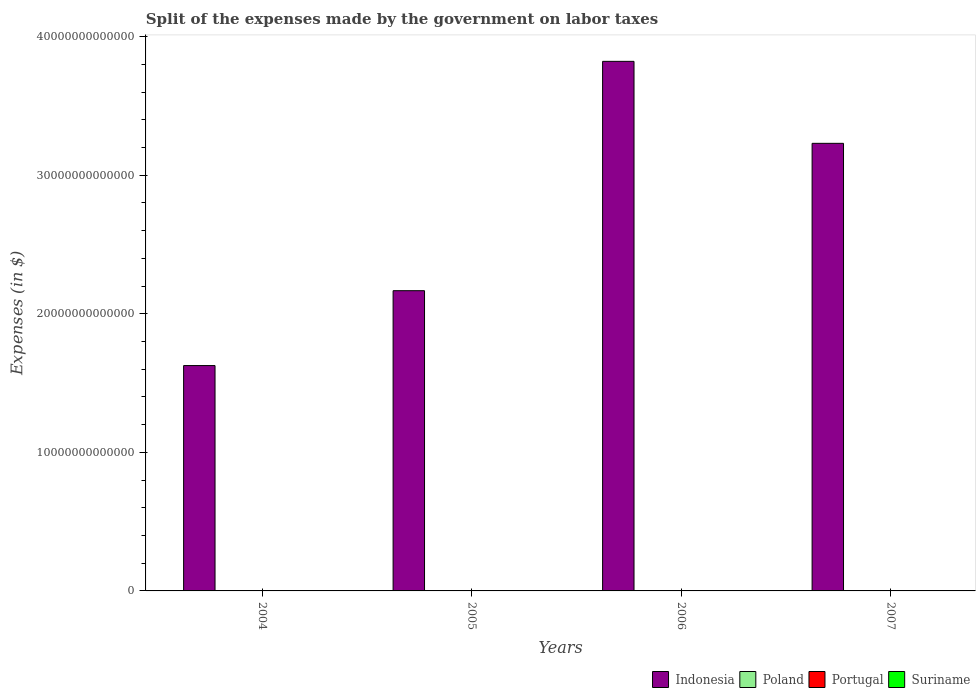How many groups of bars are there?
Provide a short and direct response. 4. Are the number of bars per tick equal to the number of legend labels?
Offer a terse response. Yes. Are the number of bars on each tick of the X-axis equal?
Make the answer very short. Yes. How many bars are there on the 4th tick from the left?
Your response must be concise. 4. In how many cases, is the number of bars for a given year not equal to the number of legend labels?
Make the answer very short. 0. What is the expenses made by the government on labor taxes in Suriname in 2007?
Offer a very short reply. 7.59e+07. Across all years, what is the maximum expenses made by the government on labor taxes in Suriname?
Make the answer very short. 7.59e+07. Across all years, what is the minimum expenses made by the government on labor taxes in Portugal?
Your answer should be compact. 1.18e+09. In which year was the expenses made by the government on labor taxes in Poland maximum?
Your answer should be compact. 2007. In which year was the expenses made by the government on labor taxes in Portugal minimum?
Offer a terse response. 2004. What is the total expenses made by the government on labor taxes in Portugal in the graph?
Your answer should be very brief. 5.30e+09. What is the difference between the expenses made by the government on labor taxes in Indonesia in 2005 and that in 2006?
Give a very brief answer. -1.65e+13. What is the difference between the expenses made by the government on labor taxes in Indonesia in 2006 and the expenses made by the government on labor taxes in Portugal in 2004?
Offer a terse response. 3.82e+13. What is the average expenses made by the government on labor taxes in Poland per year?
Keep it short and to the point. 2.67e+09. In the year 2004, what is the difference between the expenses made by the government on labor taxes in Suriname and expenses made by the government on labor taxes in Indonesia?
Your answer should be very brief. -1.63e+13. What is the ratio of the expenses made by the government on labor taxes in Indonesia in 2005 to that in 2006?
Offer a very short reply. 0.57. Is the difference between the expenses made by the government on labor taxes in Suriname in 2005 and 2007 greater than the difference between the expenses made by the government on labor taxes in Indonesia in 2005 and 2007?
Make the answer very short. Yes. What is the difference between the highest and the second highest expenses made by the government on labor taxes in Poland?
Give a very brief answer. 1.49e+08. What is the difference between the highest and the lowest expenses made by the government on labor taxes in Indonesia?
Provide a short and direct response. 2.20e+13. What does the 1st bar from the left in 2006 represents?
Give a very brief answer. Indonesia. How many bars are there?
Ensure brevity in your answer.  16. Are all the bars in the graph horizontal?
Offer a terse response. No. How many years are there in the graph?
Your answer should be very brief. 4. What is the difference between two consecutive major ticks on the Y-axis?
Provide a succinct answer. 1.00e+13. Does the graph contain grids?
Give a very brief answer. No. Where does the legend appear in the graph?
Your response must be concise. Bottom right. What is the title of the graph?
Ensure brevity in your answer.  Split of the expenses made by the government on labor taxes. Does "Spain" appear as one of the legend labels in the graph?
Your answer should be very brief. No. What is the label or title of the Y-axis?
Provide a succinct answer. Expenses (in $). What is the Expenses (in $) of Indonesia in 2004?
Provide a succinct answer. 1.63e+13. What is the Expenses (in $) of Poland in 2004?
Offer a terse response. 2.17e+09. What is the Expenses (in $) in Portugal in 2004?
Give a very brief answer. 1.18e+09. What is the Expenses (in $) of Suriname in 2004?
Provide a short and direct response. 4.07e+07. What is the Expenses (in $) of Indonesia in 2005?
Your answer should be compact. 2.17e+13. What is the Expenses (in $) in Poland in 2005?
Provide a succinct answer. 2.50e+09. What is the Expenses (in $) of Portugal in 2005?
Make the answer very short. 1.29e+09. What is the Expenses (in $) in Suriname in 2005?
Provide a short and direct response. 4.94e+07. What is the Expenses (in $) in Indonesia in 2006?
Make the answer very short. 3.82e+13. What is the Expenses (in $) in Poland in 2006?
Offer a terse response. 2.93e+09. What is the Expenses (in $) of Portugal in 2006?
Keep it short and to the point. 1.39e+09. What is the Expenses (in $) of Suriname in 2006?
Make the answer very short. 6.16e+07. What is the Expenses (in $) in Indonesia in 2007?
Offer a very short reply. 3.23e+13. What is the Expenses (in $) in Poland in 2007?
Make the answer very short. 3.08e+09. What is the Expenses (in $) in Portugal in 2007?
Give a very brief answer. 1.44e+09. What is the Expenses (in $) in Suriname in 2007?
Provide a succinct answer. 7.59e+07. Across all years, what is the maximum Expenses (in $) of Indonesia?
Offer a terse response. 3.82e+13. Across all years, what is the maximum Expenses (in $) in Poland?
Make the answer very short. 3.08e+09. Across all years, what is the maximum Expenses (in $) in Portugal?
Keep it short and to the point. 1.44e+09. Across all years, what is the maximum Expenses (in $) in Suriname?
Your answer should be compact. 7.59e+07. Across all years, what is the minimum Expenses (in $) of Indonesia?
Your response must be concise. 1.63e+13. Across all years, what is the minimum Expenses (in $) of Poland?
Keep it short and to the point. 2.17e+09. Across all years, what is the minimum Expenses (in $) in Portugal?
Offer a very short reply. 1.18e+09. Across all years, what is the minimum Expenses (in $) in Suriname?
Keep it short and to the point. 4.07e+07. What is the total Expenses (in $) of Indonesia in the graph?
Offer a terse response. 1.08e+14. What is the total Expenses (in $) in Poland in the graph?
Give a very brief answer. 1.07e+1. What is the total Expenses (in $) in Portugal in the graph?
Give a very brief answer. 5.30e+09. What is the total Expenses (in $) of Suriname in the graph?
Your answer should be compact. 2.28e+08. What is the difference between the Expenses (in $) of Indonesia in 2004 and that in 2005?
Ensure brevity in your answer.  -5.40e+12. What is the difference between the Expenses (in $) in Poland in 2004 and that in 2005?
Your answer should be compact. -3.30e+08. What is the difference between the Expenses (in $) in Portugal in 2004 and that in 2005?
Your answer should be very brief. -1.15e+08. What is the difference between the Expenses (in $) of Suriname in 2004 and that in 2005?
Your answer should be very brief. -8.70e+06. What is the difference between the Expenses (in $) in Indonesia in 2004 and that in 2006?
Make the answer very short. -2.20e+13. What is the difference between the Expenses (in $) in Poland in 2004 and that in 2006?
Your answer should be compact. -7.57e+08. What is the difference between the Expenses (in $) of Portugal in 2004 and that in 2006?
Keep it short and to the point. -2.15e+08. What is the difference between the Expenses (in $) in Suriname in 2004 and that in 2006?
Provide a short and direct response. -2.09e+07. What is the difference between the Expenses (in $) of Indonesia in 2004 and that in 2007?
Offer a terse response. -1.60e+13. What is the difference between the Expenses (in $) of Poland in 2004 and that in 2007?
Offer a terse response. -9.06e+08. What is the difference between the Expenses (in $) of Portugal in 2004 and that in 2007?
Give a very brief answer. -2.58e+08. What is the difference between the Expenses (in $) of Suriname in 2004 and that in 2007?
Make the answer very short. -3.51e+07. What is the difference between the Expenses (in $) of Indonesia in 2005 and that in 2006?
Offer a terse response. -1.65e+13. What is the difference between the Expenses (in $) of Poland in 2005 and that in 2006?
Provide a short and direct response. -4.27e+08. What is the difference between the Expenses (in $) of Portugal in 2005 and that in 2006?
Offer a very short reply. -1.00e+08. What is the difference between the Expenses (in $) in Suriname in 2005 and that in 2006?
Offer a terse response. -1.22e+07. What is the difference between the Expenses (in $) of Indonesia in 2005 and that in 2007?
Offer a very short reply. -1.06e+13. What is the difference between the Expenses (in $) of Poland in 2005 and that in 2007?
Your response must be concise. -5.76e+08. What is the difference between the Expenses (in $) of Portugal in 2005 and that in 2007?
Provide a short and direct response. -1.43e+08. What is the difference between the Expenses (in $) of Suriname in 2005 and that in 2007?
Offer a very short reply. -2.64e+07. What is the difference between the Expenses (in $) of Indonesia in 2006 and that in 2007?
Provide a short and direct response. 5.92e+12. What is the difference between the Expenses (in $) in Poland in 2006 and that in 2007?
Keep it short and to the point. -1.49e+08. What is the difference between the Expenses (in $) in Portugal in 2006 and that in 2007?
Make the answer very short. -4.29e+07. What is the difference between the Expenses (in $) in Suriname in 2006 and that in 2007?
Your response must be concise. -1.43e+07. What is the difference between the Expenses (in $) in Indonesia in 2004 and the Expenses (in $) in Poland in 2005?
Your answer should be very brief. 1.63e+13. What is the difference between the Expenses (in $) of Indonesia in 2004 and the Expenses (in $) of Portugal in 2005?
Give a very brief answer. 1.63e+13. What is the difference between the Expenses (in $) of Indonesia in 2004 and the Expenses (in $) of Suriname in 2005?
Your answer should be very brief. 1.63e+13. What is the difference between the Expenses (in $) in Poland in 2004 and the Expenses (in $) in Portugal in 2005?
Your answer should be compact. 8.81e+08. What is the difference between the Expenses (in $) of Poland in 2004 and the Expenses (in $) of Suriname in 2005?
Keep it short and to the point. 2.12e+09. What is the difference between the Expenses (in $) in Portugal in 2004 and the Expenses (in $) in Suriname in 2005?
Your answer should be compact. 1.13e+09. What is the difference between the Expenses (in $) of Indonesia in 2004 and the Expenses (in $) of Poland in 2006?
Offer a terse response. 1.63e+13. What is the difference between the Expenses (in $) in Indonesia in 2004 and the Expenses (in $) in Portugal in 2006?
Ensure brevity in your answer.  1.63e+13. What is the difference between the Expenses (in $) in Indonesia in 2004 and the Expenses (in $) in Suriname in 2006?
Your response must be concise. 1.63e+13. What is the difference between the Expenses (in $) of Poland in 2004 and the Expenses (in $) of Portugal in 2006?
Your response must be concise. 7.80e+08. What is the difference between the Expenses (in $) of Poland in 2004 and the Expenses (in $) of Suriname in 2006?
Your response must be concise. 2.11e+09. What is the difference between the Expenses (in $) in Portugal in 2004 and the Expenses (in $) in Suriname in 2006?
Your answer should be compact. 1.12e+09. What is the difference between the Expenses (in $) of Indonesia in 2004 and the Expenses (in $) of Poland in 2007?
Your answer should be very brief. 1.63e+13. What is the difference between the Expenses (in $) in Indonesia in 2004 and the Expenses (in $) in Portugal in 2007?
Offer a terse response. 1.63e+13. What is the difference between the Expenses (in $) in Indonesia in 2004 and the Expenses (in $) in Suriname in 2007?
Offer a very short reply. 1.63e+13. What is the difference between the Expenses (in $) in Poland in 2004 and the Expenses (in $) in Portugal in 2007?
Keep it short and to the point. 7.38e+08. What is the difference between the Expenses (in $) of Poland in 2004 and the Expenses (in $) of Suriname in 2007?
Provide a short and direct response. 2.10e+09. What is the difference between the Expenses (in $) in Portugal in 2004 and the Expenses (in $) in Suriname in 2007?
Your answer should be compact. 1.10e+09. What is the difference between the Expenses (in $) of Indonesia in 2005 and the Expenses (in $) of Poland in 2006?
Make the answer very short. 2.17e+13. What is the difference between the Expenses (in $) of Indonesia in 2005 and the Expenses (in $) of Portugal in 2006?
Provide a succinct answer. 2.17e+13. What is the difference between the Expenses (in $) in Indonesia in 2005 and the Expenses (in $) in Suriname in 2006?
Provide a short and direct response. 2.17e+13. What is the difference between the Expenses (in $) in Poland in 2005 and the Expenses (in $) in Portugal in 2006?
Offer a terse response. 1.11e+09. What is the difference between the Expenses (in $) in Poland in 2005 and the Expenses (in $) in Suriname in 2006?
Make the answer very short. 2.44e+09. What is the difference between the Expenses (in $) in Portugal in 2005 and the Expenses (in $) in Suriname in 2006?
Provide a succinct answer. 1.23e+09. What is the difference between the Expenses (in $) of Indonesia in 2005 and the Expenses (in $) of Poland in 2007?
Your answer should be very brief. 2.17e+13. What is the difference between the Expenses (in $) in Indonesia in 2005 and the Expenses (in $) in Portugal in 2007?
Your answer should be very brief. 2.17e+13. What is the difference between the Expenses (in $) of Indonesia in 2005 and the Expenses (in $) of Suriname in 2007?
Provide a short and direct response. 2.17e+13. What is the difference between the Expenses (in $) in Poland in 2005 and the Expenses (in $) in Portugal in 2007?
Give a very brief answer. 1.07e+09. What is the difference between the Expenses (in $) of Poland in 2005 and the Expenses (in $) of Suriname in 2007?
Offer a terse response. 2.43e+09. What is the difference between the Expenses (in $) in Portugal in 2005 and the Expenses (in $) in Suriname in 2007?
Your answer should be compact. 1.22e+09. What is the difference between the Expenses (in $) of Indonesia in 2006 and the Expenses (in $) of Poland in 2007?
Make the answer very short. 3.82e+13. What is the difference between the Expenses (in $) in Indonesia in 2006 and the Expenses (in $) in Portugal in 2007?
Provide a short and direct response. 3.82e+13. What is the difference between the Expenses (in $) of Indonesia in 2006 and the Expenses (in $) of Suriname in 2007?
Provide a short and direct response. 3.82e+13. What is the difference between the Expenses (in $) of Poland in 2006 and the Expenses (in $) of Portugal in 2007?
Make the answer very short. 1.49e+09. What is the difference between the Expenses (in $) of Poland in 2006 and the Expenses (in $) of Suriname in 2007?
Your answer should be very brief. 2.86e+09. What is the difference between the Expenses (in $) of Portugal in 2006 and the Expenses (in $) of Suriname in 2007?
Offer a terse response. 1.32e+09. What is the average Expenses (in $) in Indonesia per year?
Your answer should be compact. 2.71e+13. What is the average Expenses (in $) of Poland per year?
Keep it short and to the point. 2.67e+09. What is the average Expenses (in $) of Portugal per year?
Provide a succinct answer. 1.33e+09. What is the average Expenses (in $) in Suriname per year?
Give a very brief answer. 5.69e+07. In the year 2004, what is the difference between the Expenses (in $) in Indonesia and Expenses (in $) in Poland?
Keep it short and to the point. 1.63e+13. In the year 2004, what is the difference between the Expenses (in $) in Indonesia and Expenses (in $) in Portugal?
Ensure brevity in your answer.  1.63e+13. In the year 2004, what is the difference between the Expenses (in $) in Indonesia and Expenses (in $) in Suriname?
Your answer should be very brief. 1.63e+13. In the year 2004, what is the difference between the Expenses (in $) of Poland and Expenses (in $) of Portugal?
Provide a short and direct response. 9.96e+08. In the year 2004, what is the difference between the Expenses (in $) in Poland and Expenses (in $) in Suriname?
Give a very brief answer. 2.13e+09. In the year 2004, what is the difference between the Expenses (in $) in Portugal and Expenses (in $) in Suriname?
Provide a succinct answer. 1.14e+09. In the year 2005, what is the difference between the Expenses (in $) of Indonesia and Expenses (in $) of Poland?
Keep it short and to the point. 2.17e+13. In the year 2005, what is the difference between the Expenses (in $) in Indonesia and Expenses (in $) in Portugal?
Ensure brevity in your answer.  2.17e+13. In the year 2005, what is the difference between the Expenses (in $) of Indonesia and Expenses (in $) of Suriname?
Give a very brief answer. 2.17e+13. In the year 2005, what is the difference between the Expenses (in $) of Poland and Expenses (in $) of Portugal?
Give a very brief answer. 1.21e+09. In the year 2005, what is the difference between the Expenses (in $) of Poland and Expenses (in $) of Suriname?
Provide a succinct answer. 2.45e+09. In the year 2005, what is the difference between the Expenses (in $) of Portugal and Expenses (in $) of Suriname?
Your response must be concise. 1.24e+09. In the year 2006, what is the difference between the Expenses (in $) of Indonesia and Expenses (in $) of Poland?
Provide a short and direct response. 3.82e+13. In the year 2006, what is the difference between the Expenses (in $) in Indonesia and Expenses (in $) in Portugal?
Keep it short and to the point. 3.82e+13. In the year 2006, what is the difference between the Expenses (in $) in Indonesia and Expenses (in $) in Suriname?
Provide a succinct answer. 3.82e+13. In the year 2006, what is the difference between the Expenses (in $) in Poland and Expenses (in $) in Portugal?
Provide a short and direct response. 1.54e+09. In the year 2006, what is the difference between the Expenses (in $) of Poland and Expenses (in $) of Suriname?
Make the answer very short. 2.87e+09. In the year 2006, what is the difference between the Expenses (in $) of Portugal and Expenses (in $) of Suriname?
Your answer should be compact. 1.33e+09. In the year 2007, what is the difference between the Expenses (in $) in Indonesia and Expenses (in $) in Poland?
Offer a very short reply. 3.23e+13. In the year 2007, what is the difference between the Expenses (in $) in Indonesia and Expenses (in $) in Portugal?
Provide a short and direct response. 3.23e+13. In the year 2007, what is the difference between the Expenses (in $) of Indonesia and Expenses (in $) of Suriname?
Your response must be concise. 3.23e+13. In the year 2007, what is the difference between the Expenses (in $) in Poland and Expenses (in $) in Portugal?
Offer a very short reply. 1.64e+09. In the year 2007, what is the difference between the Expenses (in $) of Poland and Expenses (in $) of Suriname?
Give a very brief answer. 3.00e+09. In the year 2007, what is the difference between the Expenses (in $) of Portugal and Expenses (in $) of Suriname?
Your response must be concise. 1.36e+09. What is the ratio of the Expenses (in $) in Indonesia in 2004 to that in 2005?
Provide a short and direct response. 0.75. What is the ratio of the Expenses (in $) in Poland in 2004 to that in 2005?
Your answer should be compact. 0.87. What is the ratio of the Expenses (in $) in Portugal in 2004 to that in 2005?
Your answer should be very brief. 0.91. What is the ratio of the Expenses (in $) of Suriname in 2004 to that in 2005?
Your answer should be compact. 0.82. What is the ratio of the Expenses (in $) of Indonesia in 2004 to that in 2006?
Your response must be concise. 0.43. What is the ratio of the Expenses (in $) of Poland in 2004 to that in 2006?
Make the answer very short. 0.74. What is the ratio of the Expenses (in $) in Portugal in 2004 to that in 2006?
Make the answer very short. 0.85. What is the ratio of the Expenses (in $) of Suriname in 2004 to that in 2006?
Your answer should be compact. 0.66. What is the ratio of the Expenses (in $) in Indonesia in 2004 to that in 2007?
Ensure brevity in your answer.  0.5. What is the ratio of the Expenses (in $) of Poland in 2004 to that in 2007?
Offer a very short reply. 0.71. What is the ratio of the Expenses (in $) of Portugal in 2004 to that in 2007?
Give a very brief answer. 0.82. What is the ratio of the Expenses (in $) in Suriname in 2004 to that in 2007?
Provide a short and direct response. 0.54. What is the ratio of the Expenses (in $) in Indonesia in 2005 to that in 2006?
Give a very brief answer. 0.57. What is the ratio of the Expenses (in $) in Poland in 2005 to that in 2006?
Give a very brief answer. 0.85. What is the ratio of the Expenses (in $) in Portugal in 2005 to that in 2006?
Your answer should be compact. 0.93. What is the ratio of the Expenses (in $) in Suriname in 2005 to that in 2006?
Offer a very short reply. 0.8. What is the ratio of the Expenses (in $) of Indonesia in 2005 to that in 2007?
Your response must be concise. 0.67. What is the ratio of the Expenses (in $) of Poland in 2005 to that in 2007?
Ensure brevity in your answer.  0.81. What is the ratio of the Expenses (in $) of Portugal in 2005 to that in 2007?
Offer a very short reply. 0.9. What is the ratio of the Expenses (in $) in Suriname in 2005 to that in 2007?
Make the answer very short. 0.65. What is the ratio of the Expenses (in $) in Indonesia in 2006 to that in 2007?
Offer a very short reply. 1.18. What is the ratio of the Expenses (in $) in Poland in 2006 to that in 2007?
Your answer should be compact. 0.95. What is the ratio of the Expenses (in $) in Portugal in 2006 to that in 2007?
Ensure brevity in your answer.  0.97. What is the ratio of the Expenses (in $) in Suriname in 2006 to that in 2007?
Provide a short and direct response. 0.81. What is the difference between the highest and the second highest Expenses (in $) in Indonesia?
Provide a short and direct response. 5.92e+12. What is the difference between the highest and the second highest Expenses (in $) of Poland?
Provide a succinct answer. 1.49e+08. What is the difference between the highest and the second highest Expenses (in $) of Portugal?
Offer a very short reply. 4.29e+07. What is the difference between the highest and the second highest Expenses (in $) in Suriname?
Keep it short and to the point. 1.43e+07. What is the difference between the highest and the lowest Expenses (in $) in Indonesia?
Your answer should be compact. 2.20e+13. What is the difference between the highest and the lowest Expenses (in $) of Poland?
Keep it short and to the point. 9.06e+08. What is the difference between the highest and the lowest Expenses (in $) of Portugal?
Keep it short and to the point. 2.58e+08. What is the difference between the highest and the lowest Expenses (in $) in Suriname?
Give a very brief answer. 3.51e+07. 